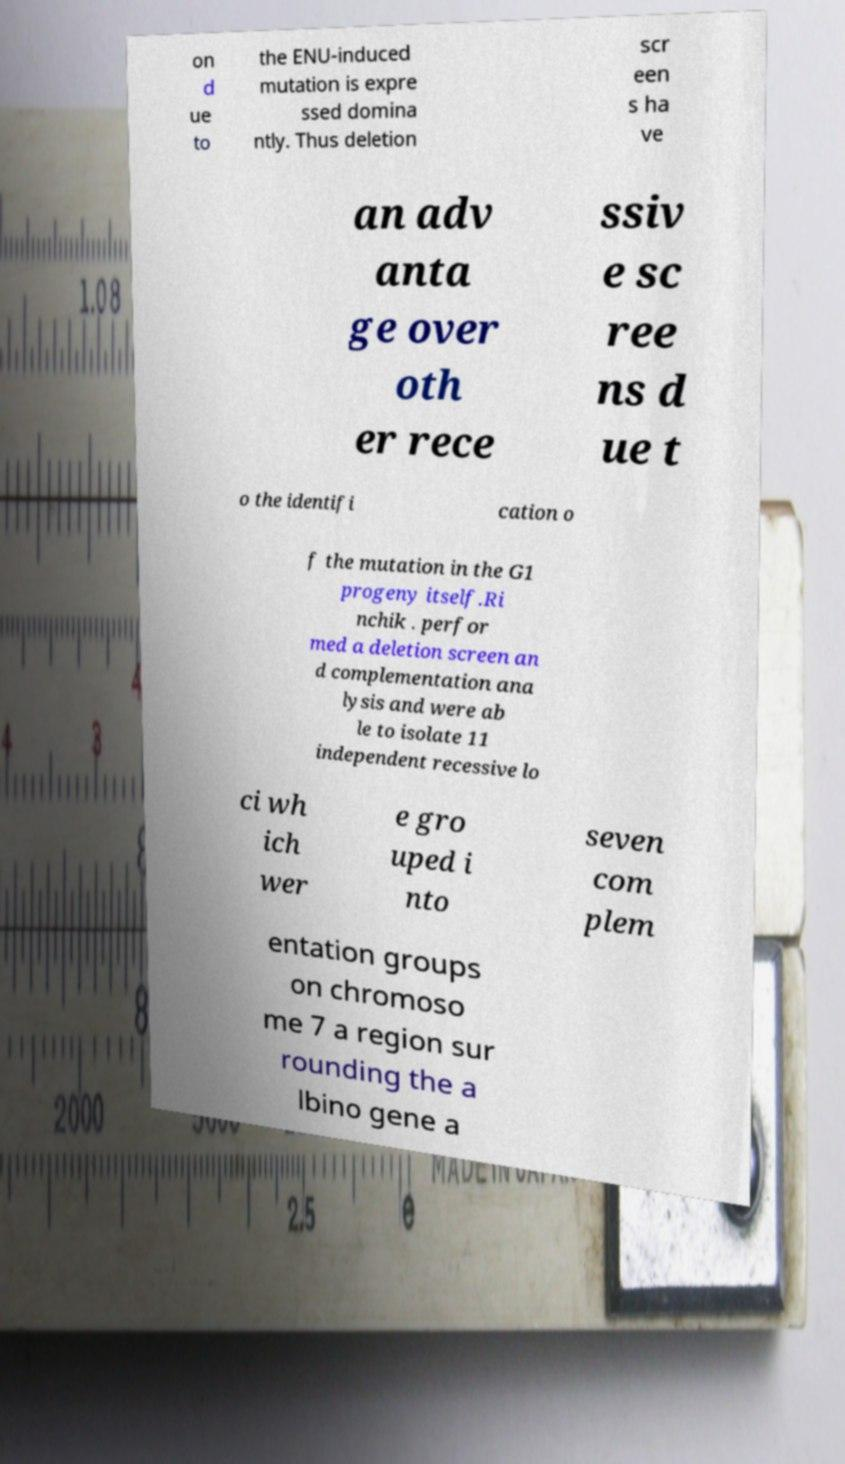What messages or text are displayed in this image? I need them in a readable, typed format. on d ue to the ENU-induced mutation is expre ssed domina ntly. Thus deletion scr een s ha ve an adv anta ge over oth er rece ssiv e sc ree ns d ue t o the identifi cation o f the mutation in the G1 progeny itself.Ri nchik . perfor med a deletion screen an d complementation ana lysis and were ab le to isolate 11 independent recessive lo ci wh ich wer e gro uped i nto seven com plem entation groups on chromoso me 7 a region sur rounding the a lbino gene a 